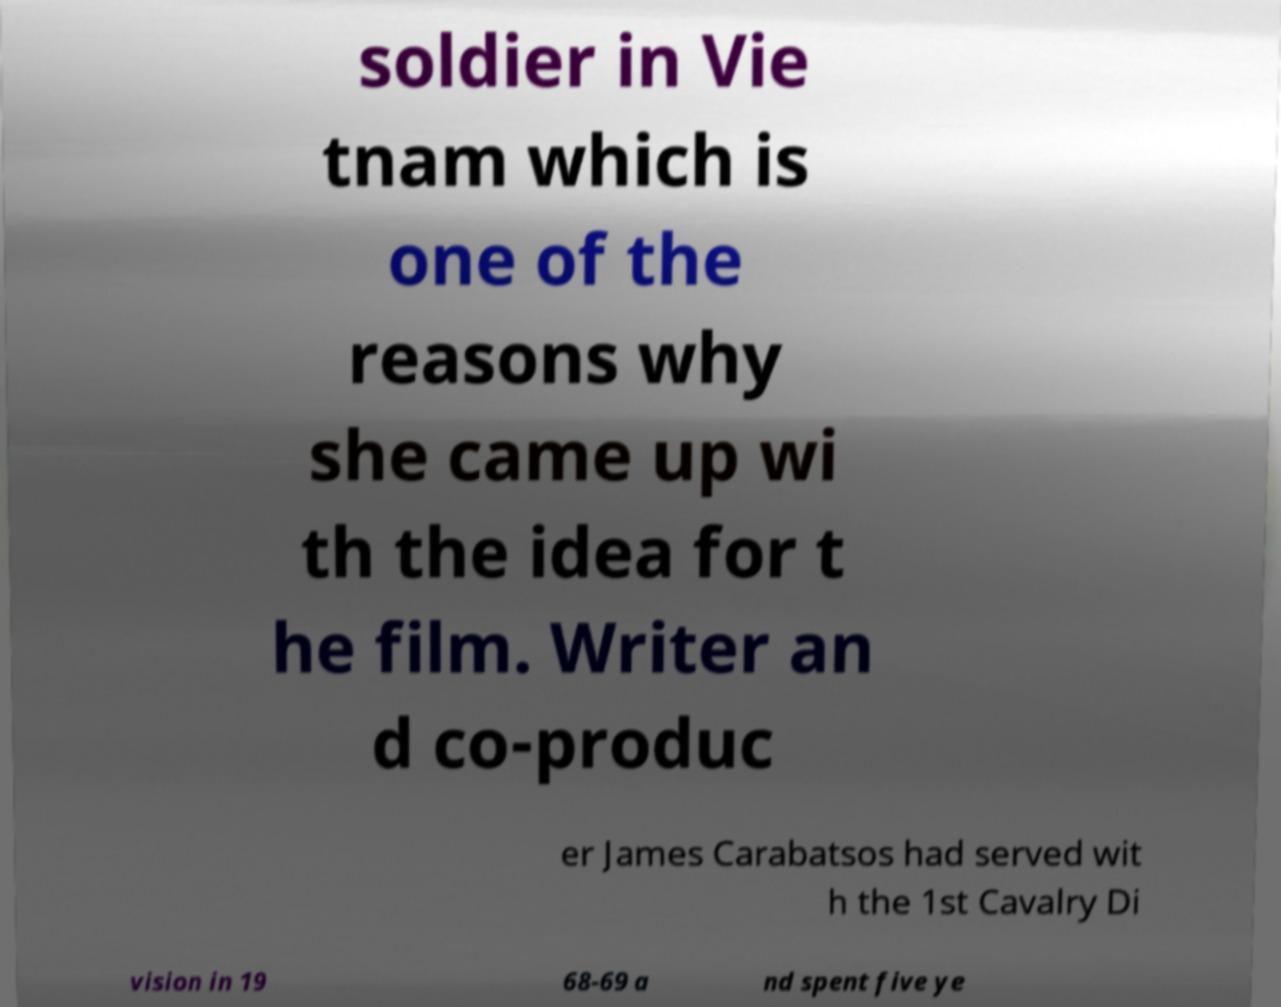Can you read and provide the text displayed in the image?This photo seems to have some interesting text. Can you extract and type it out for me? soldier in Vie tnam which is one of the reasons why she came up wi th the idea for t he film. Writer an d co-produc er James Carabatsos had served wit h the 1st Cavalry Di vision in 19 68-69 a nd spent five ye 